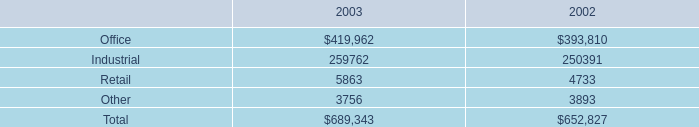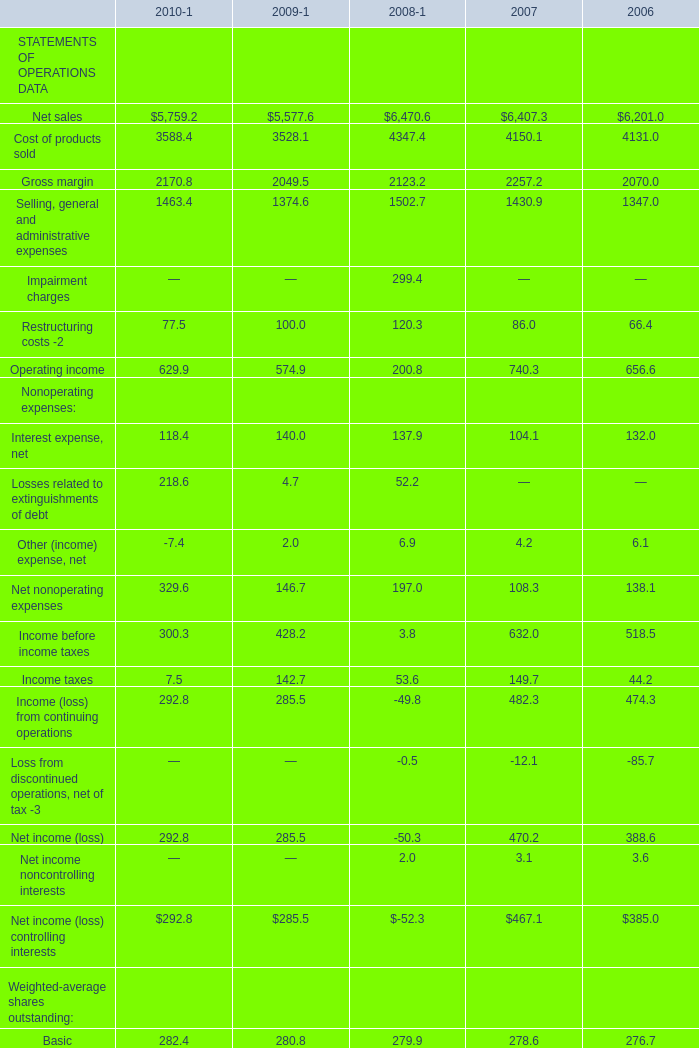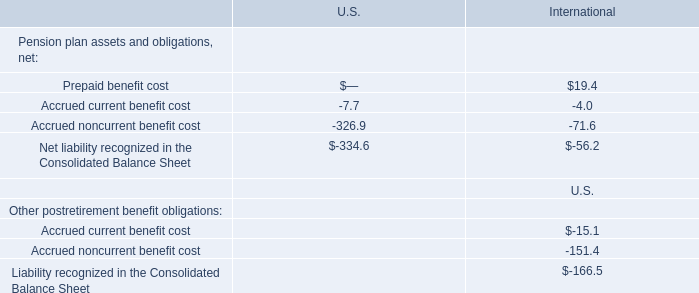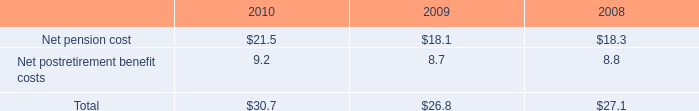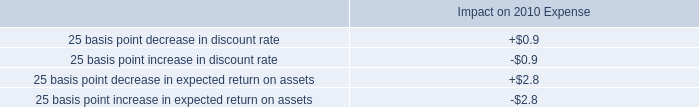What was the average value of Net income (loss), Net income noncontrolling interests, Loss from discontinued operations, net of tax -3 in 2008 
Computations: (((-50.3 + 2.0) - 0.5) / 3)
Answer: -16.26667. 